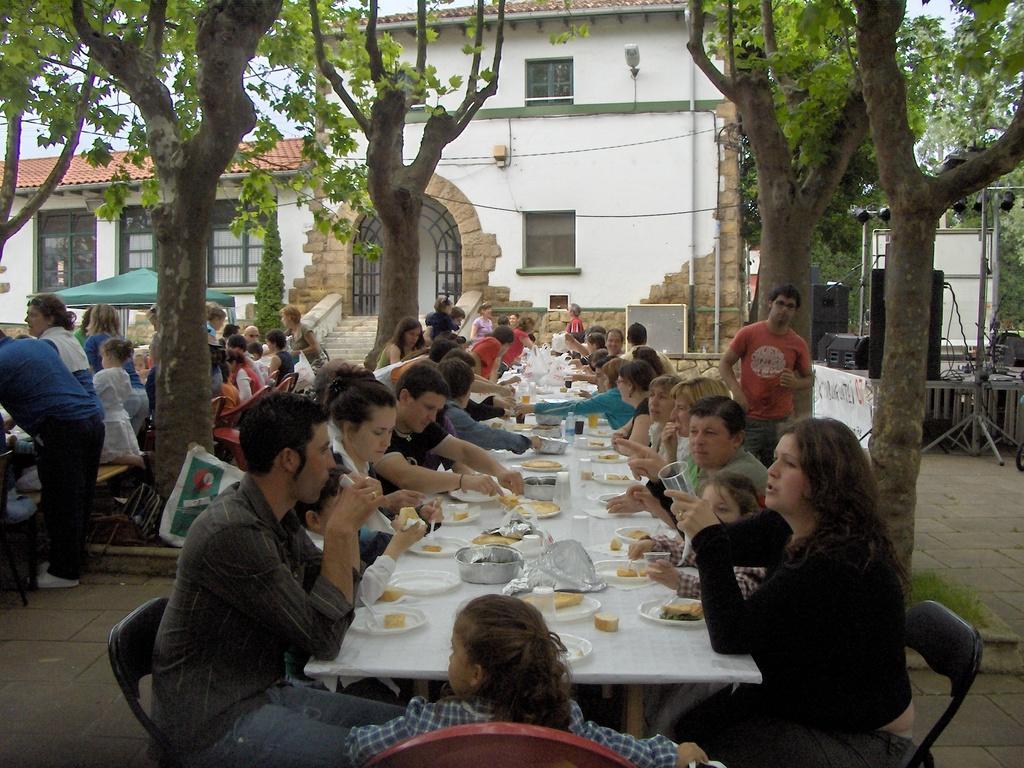In one or two sentences, can you explain what this image depicts? On the background we can see building with doors and windows. These are trees. Here we can see all the persons sitting on chairs in front of a dining table and having food. On the table we can see food items. We can see persons standing near to the table. 